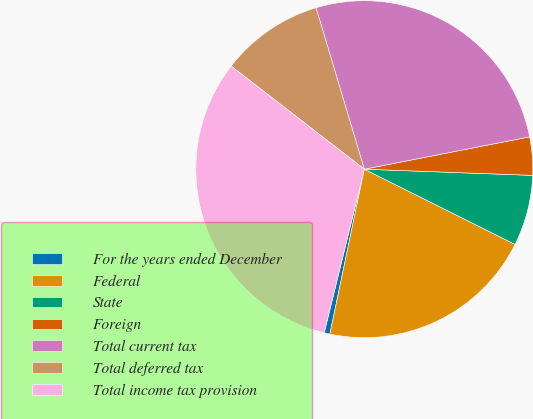Convert chart to OTSL. <chart><loc_0><loc_0><loc_500><loc_500><pie_chart><fcel>For the years ended December<fcel>Federal<fcel>State<fcel>Foreign<fcel>Total current tax<fcel>Total deferred tax<fcel>Total income tax provision<nl><fcel>0.55%<fcel>20.91%<fcel>6.78%<fcel>3.66%<fcel>26.55%<fcel>9.89%<fcel>31.66%<nl></chart> 